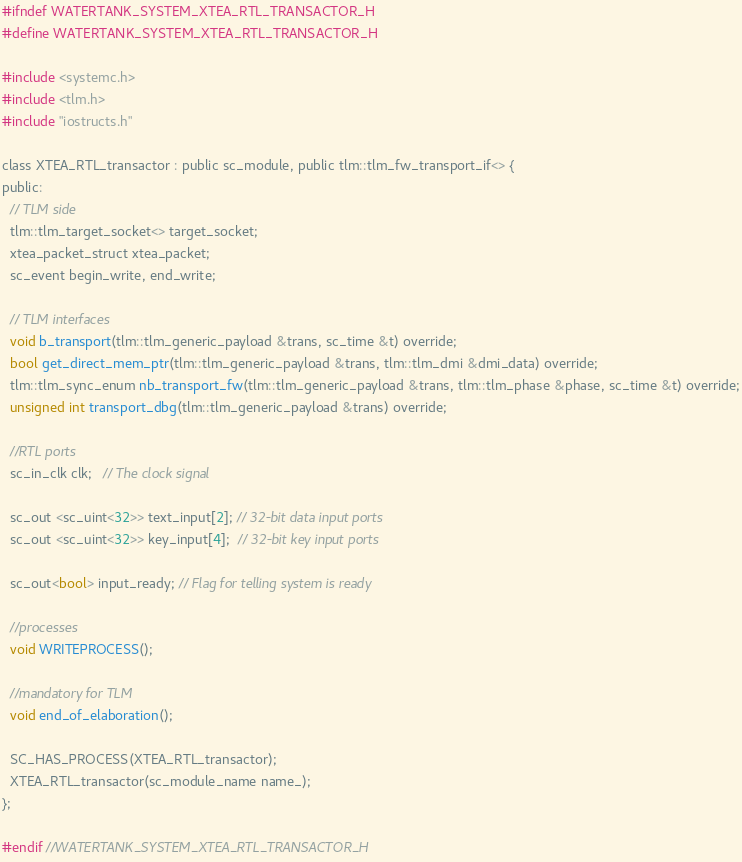<code> <loc_0><loc_0><loc_500><loc_500><_C_>#ifndef WATERTANK_SYSTEM_XTEA_RTL_TRANSACTOR_H
#define WATERTANK_SYSTEM_XTEA_RTL_TRANSACTOR_H

#include <systemc.h>
#include <tlm.h>
#include "iostructs.h"

class XTEA_RTL_transactor : public sc_module, public tlm::tlm_fw_transport_if<> {
public:
  // TLM side
  tlm::tlm_target_socket<> target_socket;
  xtea_packet_struct xtea_packet;
  sc_event begin_write, end_write;

  // TLM interfaces
  void b_transport(tlm::tlm_generic_payload &trans, sc_time &t) override;
  bool get_direct_mem_ptr(tlm::tlm_generic_payload &trans, tlm::tlm_dmi &dmi_data) override;
  tlm::tlm_sync_enum nb_transport_fw(tlm::tlm_generic_payload &trans, tlm::tlm_phase &phase, sc_time &t) override;
  unsigned int transport_dbg(tlm::tlm_generic_payload &trans) override;

  //RTL ports
  sc_in_clk clk;   // The clock signal

  sc_out <sc_uint<32>> text_input[2]; // 32-bit data input ports
  sc_out <sc_uint<32>> key_input[4];  // 32-bit key input ports

  sc_out<bool> input_ready; // Flag for telling system is ready

  //processes
  void WRITEPROCESS();

  //mandatory for TLM
  void end_of_elaboration();

  SC_HAS_PROCESS(XTEA_RTL_transactor);
  XTEA_RTL_transactor(sc_module_name name_);
};

#endif //WATERTANK_SYSTEM_XTEA_RTL_TRANSACTOR_H
</code> 